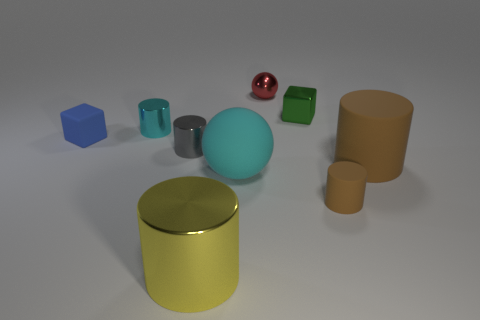Subtract all small rubber cylinders. How many cylinders are left? 4 Subtract all purple cubes. How many brown cylinders are left? 2 Subtract all cyan cylinders. How many cylinders are left? 4 Subtract all spheres. How many objects are left? 7 Subtract all red cylinders. Subtract all red cubes. How many cylinders are left? 5 Add 5 big yellow cylinders. How many big yellow cylinders are left? 6 Add 7 matte spheres. How many matte spheres exist? 8 Subtract 0 green cylinders. How many objects are left? 9 Subtract all red metal objects. Subtract all tiny red shiny things. How many objects are left? 7 